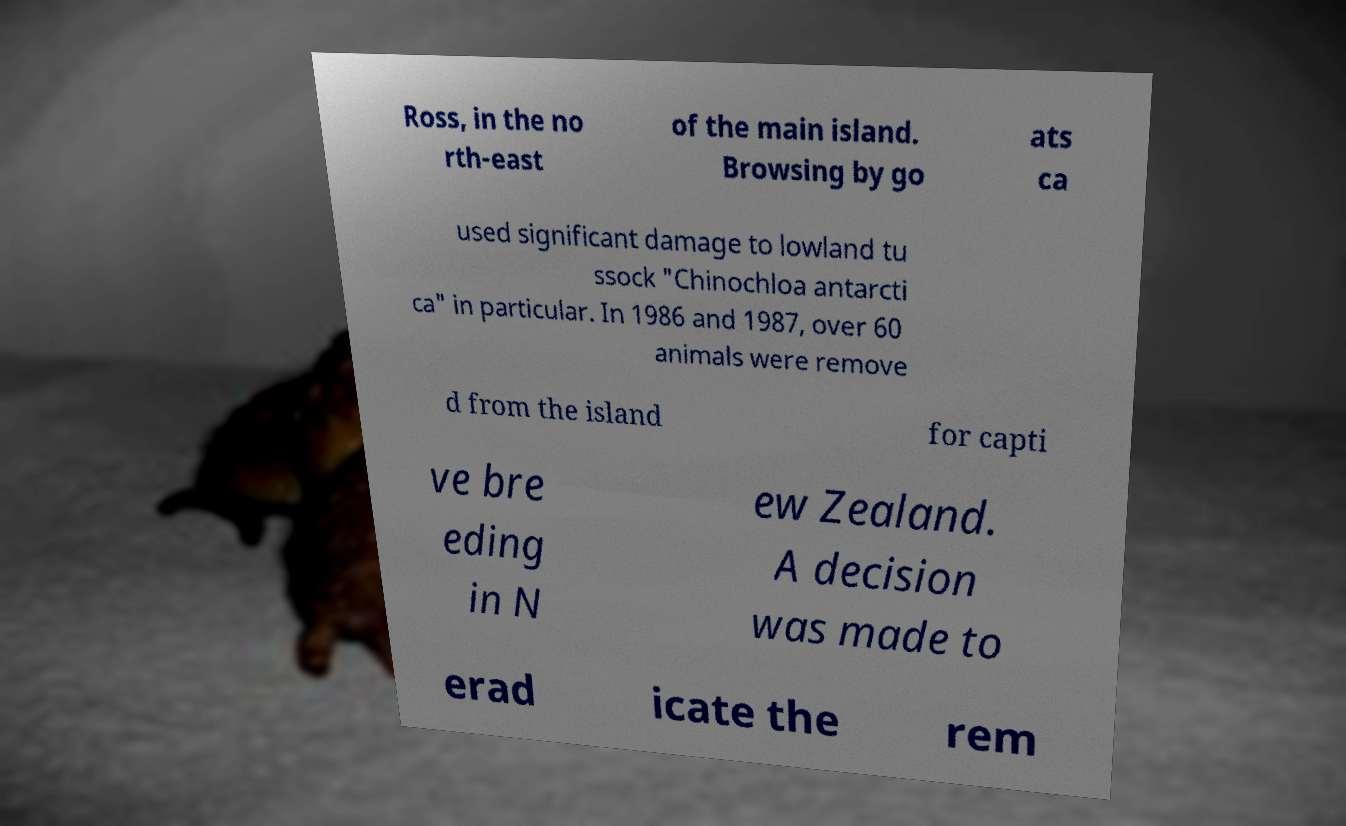Please read and relay the text visible in this image. What does it say? Ross, in the no rth-east of the main island. Browsing by go ats ca used significant damage to lowland tu ssock "Chinochloa antarcti ca" in particular. In 1986 and 1987, over 60 animals were remove d from the island for capti ve bre eding in N ew Zealand. A decision was made to erad icate the rem 